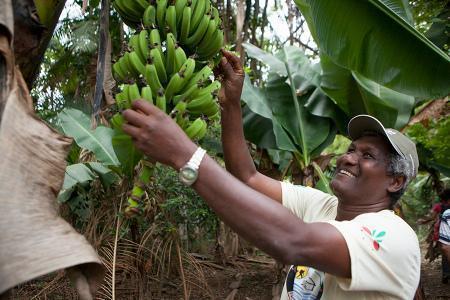How many bracelets do you see?
Give a very brief answer. 0. How many boat on the seasore?
Give a very brief answer. 0. 